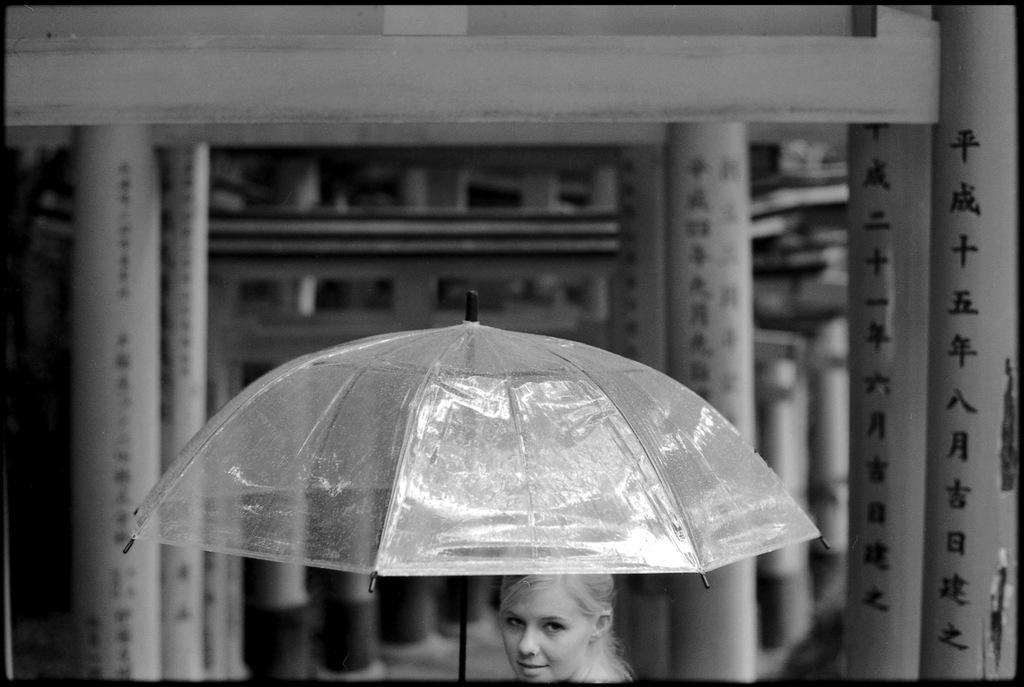How would you summarize this image in a sentence or two? It is a black and white image. In this image at front there is a person holding the umbrella. At the back side there is a building. 